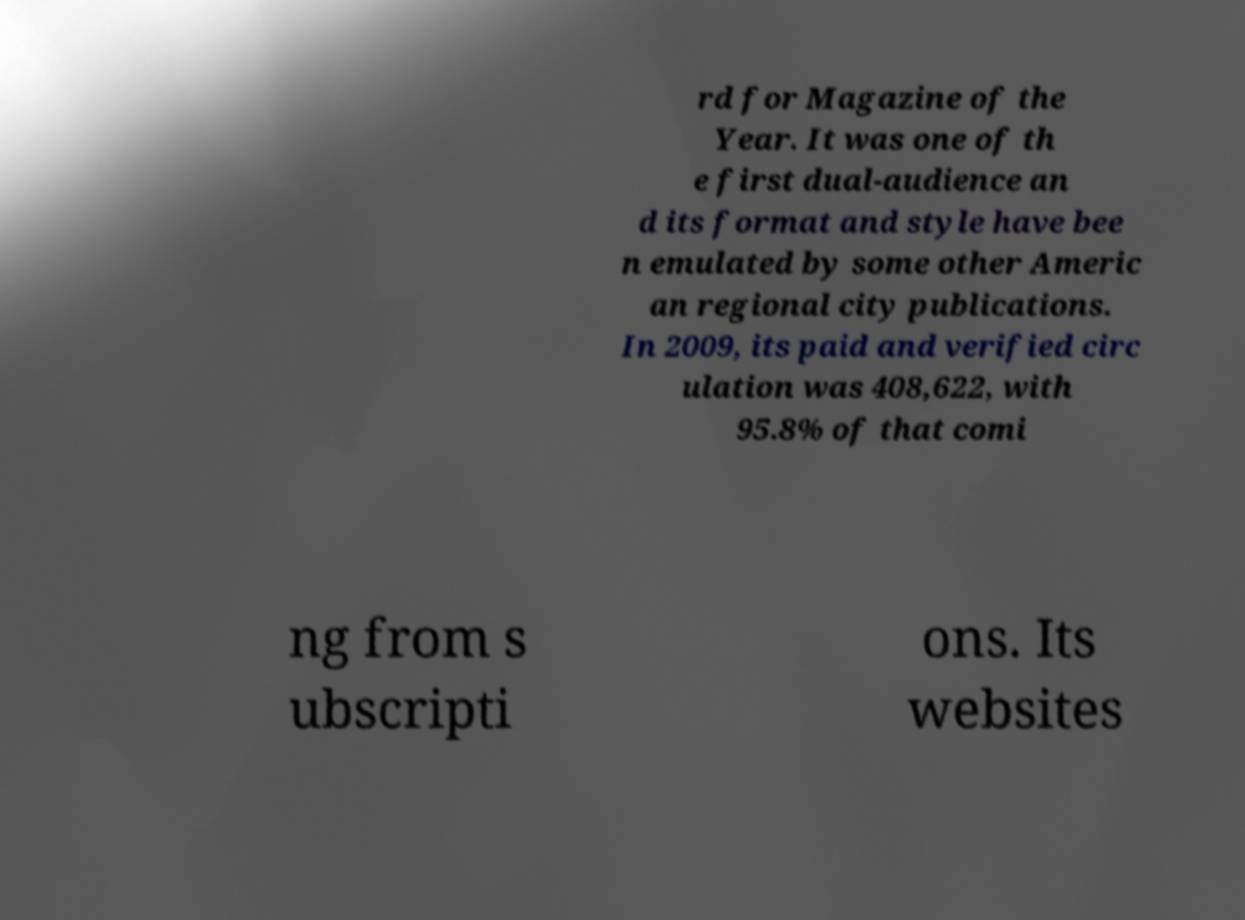Please identify and transcribe the text found in this image. rd for Magazine of the Year. It was one of th e first dual-audience an d its format and style have bee n emulated by some other Americ an regional city publications. In 2009, its paid and verified circ ulation was 408,622, with 95.8% of that comi ng from s ubscripti ons. Its websites 